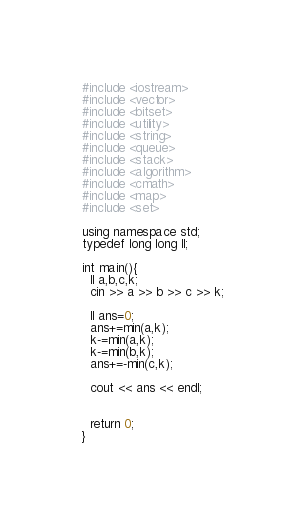<code> <loc_0><loc_0><loc_500><loc_500><_C++_>#include <iostream>
#include <vector>
#include <bitset>
#include <utility>
#include <string>
#include <queue>
#include <stack>
#include <algorithm>
#include <cmath>
#include <map>
#include <set>
 
using namespace std;
typedef long long ll;
 
int main(){
  ll a,b,c,k;
  cin >> a >> b >> c >> k;

  ll ans=0;
  ans+=min(a,k);
  k-=min(a,k);
  k-=min(b,k);
  ans+=-min(c,k);

  cout << ans << endl;


  return 0;
}
</code> 